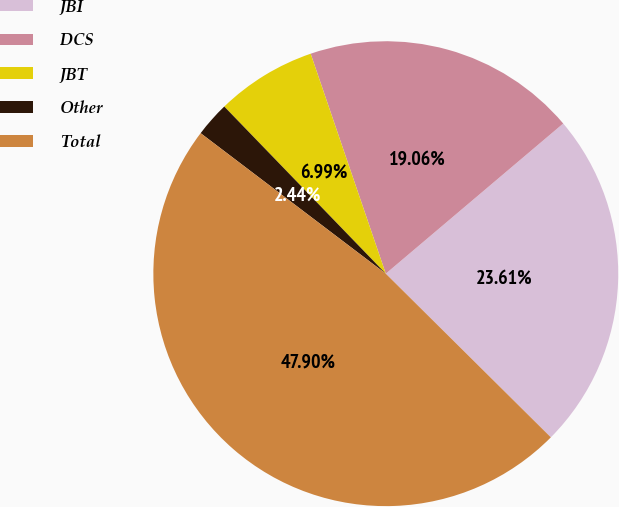Convert chart. <chart><loc_0><loc_0><loc_500><loc_500><pie_chart><fcel>JBI<fcel>DCS<fcel>JBT<fcel>Other<fcel>Total<nl><fcel>23.61%<fcel>19.06%<fcel>6.99%<fcel>2.44%<fcel>47.9%<nl></chart> 